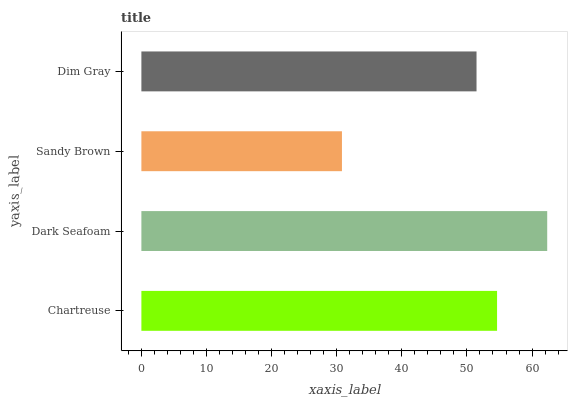Is Sandy Brown the minimum?
Answer yes or no. Yes. Is Dark Seafoam the maximum?
Answer yes or no. Yes. Is Dark Seafoam the minimum?
Answer yes or no. No. Is Sandy Brown the maximum?
Answer yes or no. No. Is Dark Seafoam greater than Sandy Brown?
Answer yes or no. Yes. Is Sandy Brown less than Dark Seafoam?
Answer yes or no. Yes. Is Sandy Brown greater than Dark Seafoam?
Answer yes or no. No. Is Dark Seafoam less than Sandy Brown?
Answer yes or no. No. Is Chartreuse the high median?
Answer yes or no. Yes. Is Dim Gray the low median?
Answer yes or no. Yes. Is Sandy Brown the high median?
Answer yes or no. No. Is Chartreuse the low median?
Answer yes or no. No. 